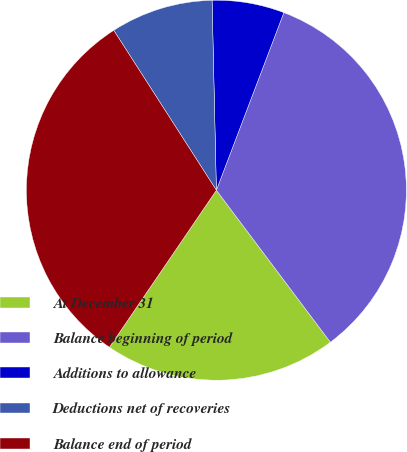Convert chart. <chart><loc_0><loc_0><loc_500><loc_500><pie_chart><fcel>At December 31<fcel>Balance beginning of period<fcel>Additions to allowance<fcel>Deductions net of recoveries<fcel>Balance end of period<nl><fcel>19.76%<fcel>33.98%<fcel>6.14%<fcel>8.72%<fcel>31.4%<nl></chart> 